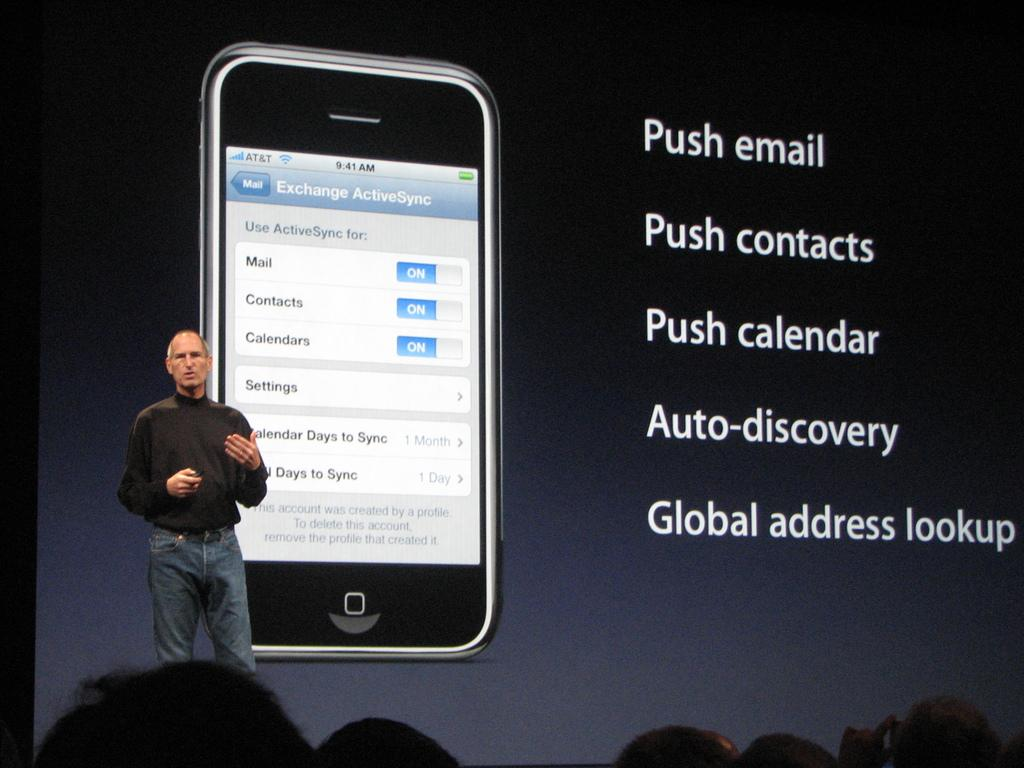Provide a one-sentence caption for the provided image. A cellphone with a mail app setting page displayed titled Exchange ActiveSync. 